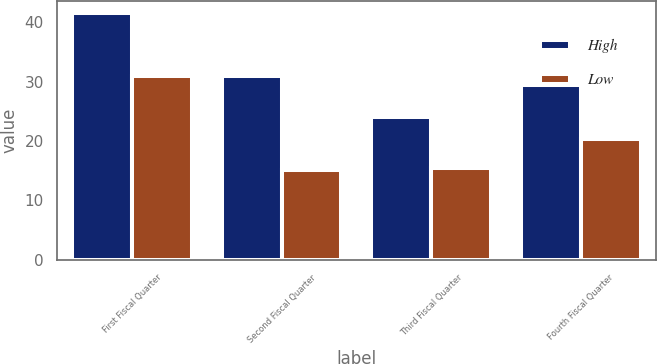<chart> <loc_0><loc_0><loc_500><loc_500><stacked_bar_chart><ecel><fcel>First Fiscal Quarter<fcel>Second Fiscal Quarter<fcel>Third Fiscal Quarter<fcel>Fourth Fiscal Quarter<nl><fcel>High<fcel>41.54<fcel>31<fcel>24.11<fcel>29.45<nl><fcel>Low<fcel>30.92<fcel>15.19<fcel>15.54<fcel>20.34<nl></chart> 